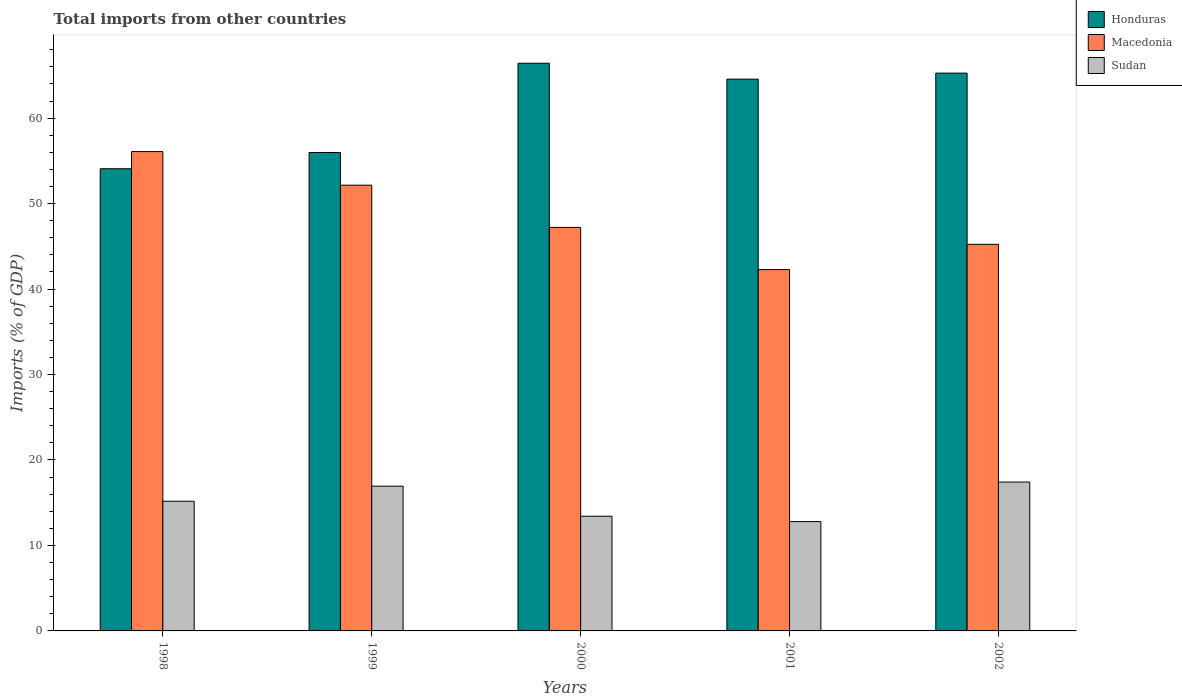How many different coloured bars are there?
Your response must be concise. 3. How many groups of bars are there?
Offer a very short reply. 5. Are the number of bars per tick equal to the number of legend labels?
Your response must be concise. Yes. Are the number of bars on each tick of the X-axis equal?
Your response must be concise. Yes. How many bars are there on the 2nd tick from the right?
Your response must be concise. 3. What is the total imports in Macedonia in 1999?
Provide a succinct answer. 52.15. Across all years, what is the maximum total imports in Sudan?
Make the answer very short. 17.42. Across all years, what is the minimum total imports in Macedonia?
Offer a very short reply. 42.28. What is the total total imports in Macedonia in the graph?
Keep it short and to the point. 242.96. What is the difference between the total imports in Honduras in 1998 and that in 1999?
Provide a succinct answer. -1.9. What is the difference between the total imports in Sudan in 2002 and the total imports in Honduras in 1999?
Your answer should be compact. -38.56. What is the average total imports in Honduras per year?
Offer a terse response. 61.26. In the year 2001, what is the difference between the total imports in Honduras and total imports in Sudan?
Ensure brevity in your answer.  51.77. In how many years, is the total imports in Honduras greater than 10 %?
Make the answer very short. 5. What is the ratio of the total imports in Sudan in 1998 to that in 2001?
Ensure brevity in your answer.  1.19. Is the total imports in Sudan in 2001 less than that in 2002?
Provide a short and direct response. Yes. What is the difference between the highest and the second highest total imports in Sudan?
Give a very brief answer. 0.48. What is the difference between the highest and the lowest total imports in Sudan?
Make the answer very short. 4.62. In how many years, is the total imports in Honduras greater than the average total imports in Honduras taken over all years?
Provide a succinct answer. 3. What does the 1st bar from the left in 1999 represents?
Your response must be concise. Honduras. What does the 3rd bar from the right in 1999 represents?
Provide a short and direct response. Honduras. Is it the case that in every year, the sum of the total imports in Macedonia and total imports in Sudan is greater than the total imports in Honduras?
Keep it short and to the point. No. How many bars are there?
Offer a very short reply. 15. Are all the bars in the graph horizontal?
Offer a very short reply. No. How many years are there in the graph?
Ensure brevity in your answer.  5. What is the difference between two consecutive major ticks on the Y-axis?
Your response must be concise. 10. Where does the legend appear in the graph?
Offer a terse response. Top right. How many legend labels are there?
Provide a short and direct response. 3. How are the legend labels stacked?
Provide a short and direct response. Vertical. What is the title of the graph?
Offer a very short reply. Total imports from other countries. Does "Turkey" appear as one of the legend labels in the graph?
Ensure brevity in your answer.  No. What is the label or title of the X-axis?
Provide a short and direct response. Years. What is the label or title of the Y-axis?
Keep it short and to the point. Imports (% of GDP). What is the Imports (% of GDP) in Honduras in 1998?
Give a very brief answer. 54.08. What is the Imports (% of GDP) in Macedonia in 1998?
Give a very brief answer. 56.09. What is the Imports (% of GDP) of Sudan in 1998?
Provide a short and direct response. 15.17. What is the Imports (% of GDP) of Honduras in 1999?
Keep it short and to the point. 55.98. What is the Imports (% of GDP) of Macedonia in 1999?
Make the answer very short. 52.15. What is the Imports (% of GDP) in Sudan in 1999?
Ensure brevity in your answer.  16.93. What is the Imports (% of GDP) in Honduras in 2000?
Keep it short and to the point. 66.42. What is the Imports (% of GDP) of Macedonia in 2000?
Your answer should be very brief. 47.21. What is the Imports (% of GDP) in Sudan in 2000?
Keep it short and to the point. 13.42. What is the Imports (% of GDP) of Honduras in 2001?
Your answer should be very brief. 64.56. What is the Imports (% of GDP) of Macedonia in 2001?
Give a very brief answer. 42.28. What is the Imports (% of GDP) of Sudan in 2001?
Give a very brief answer. 12.8. What is the Imports (% of GDP) of Honduras in 2002?
Your answer should be very brief. 65.27. What is the Imports (% of GDP) of Macedonia in 2002?
Make the answer very short. 45.23. What is the Imports (% of GDP) of Sudan in 2002?
Your answer should be very brief. 17.42. Across all years, what is the maximum Imports (% of GDP) of Honduras?
Offer a very short reply. 66.42. Across all years, what is the maximum Imports (% of GDP) of Macedonia?
Keep it short and to the point. 56.09. Across all years, what is the maximum Imports (% of GDP) in Sudan?
Your answer should be compact. 17.42. Across all years, what is the minimum Imports (% of GDP) of Honduras?
Keep it short and to the point. 54.08. Across all years, what is the minimum Imports (% of GDP) of Macedonia?
Your answer should be very brief. 42.28. Across all years, what is the minimum Imports (% of GDP) in Sudan?
Offer a very short reply. 12.8. What is the total Imports (% of GDP) of Honduras in the graph?
Give a very brief answer. 306.31. What is the total Imports (% of GDP) in Macedonia in the graph?
Give a very brief answer. 242.96. What is the total Imports (% of GDP) in Sudan in the graph?
Your response must be concise. 75.74. What is the difference between the Imports (% of GDP) of Honduras in 1998 and that in 1999?
Your answer should be compact. -1.9. What is the difference between the Imports (% of GDP) in Macedonia in 1998 and that in 1999?
Ensure brevity in your answer.  3.93. What is the difference between the Imports (% of GDP) of Sudan in 1998 and that in 1999?
Give a very brief answer. -1.76. What is the difference between the Imports (% of GDP) in Honduras in 1998 and that in 2000?
Your response must be concise. -12.34. What is the difference between the Imports (% of GDP) in Macedonia in 1998 and that in 2000?
Give a very brief answer. 8.87. What is the difference between the Imports (% of GDP) of Sudan in 1998 and that in 2000?
Offer a very short reply. 1.75. What is the difference between the Imports (% of GDP) in Honduras in 1998 and that in 2001?
Your answer should be very brief. -10.48. What is the difference between the Imports (% of GDP) in Macedonia in 1998 and that in 2001?
Ensure brevity in your answer.  13.81. What is the difference between the Imports (% of GDP) in Sudan in 1998 and that in 2001?
Your answer should be compact. 2.38. What is the difference between the Imports (% of GDP) in Honduras in 1998 and that in 2002?
Give a very brief answer. -11.19. What is the difference between the Imports (% of GDP) in Macedonia in 1998 and that in 2002?
Give a very brief answer. 10.85. What is the difference between the Imports (% of GDP) in Sudan in 1998 and that in 2002?
Give a very brief answer. -2.24. What is the difference between the Imports (% of GDP) in Honduras in 1999 and that in 2000?
Ensure brevity in your answer.  -10.44. What is the difference between the Imports (% of GDP) in Macedonia in 1999 and that in 2000?
Ensure brevity in your answer.  4.94. What is the difference between the Imports (% of GDP) of Sudan in 1999 and that in 2000?
Provide a succinct answer. 3.52. What is the difference between the Imports (% of GDP) of Honduras in 1999 and that in 2001?
Ensure brevity in your answer.  -8.58. What is the difference between the Imports (% of GDP) of Macedonia in 1999 and that in 2001?
Ensure brevity in your answer.  9.87. What is the difference between the Imports (% of GDP) in Sudan in 1999 and that in 2001?
Give a very brief answer. 4.14. What is the difference between the Imports (% of GDP) in Honduras in 1999 and that in 2002?
Give a very brief answer. -9.29. What is the difference between the Imports (% of GDP) of Macedonia in 1999 and that in 2002?
Your answer should be compact. 6.92. What is the difference between the Imports (% of GDP) in Sudan in 1999 and that in 2002?
Keep it short and to the point. -0.48. What is the difference between the Imports (% of GDP) of Honduras in 2000 and that in 2001?
Make the answer very short. 1.86. What is the difference between the Imports (% of GDP) in Macedonia in 2000 and that in 2001?
Provide a succinct answer. 4.93. What is the difference between the Imports (% of GDP) of Sudan in 2000 and that in 2001?
Your answer should be very brief. 0.62. What is the difference between the Imports (% of GDP) in Honduras in 2000 and that in 2002?
Give a very brief answer. 1.15. What is the difference between the Imports (% of GDP) in Macedonia in 2000 and that in 2002?
Offer a terse response. 1.98. What is the difference between the Imports (% of GDP) in Sudan in 2000 and that in 2002?
Keep it short and to the point. -4. What is the difference between the Imports (% of GDP) in Honduras in 2001 and that in 2002?
Keep it short and to the point. -0.71. What is the difference between the Imports (% of GDP) of Macedonia in 2001 and that in 2002?
Ensure brevity in your answer.  -2.95. What is the difference between the Imports (% of GDP) of Sudan in 2001 and that in 2002?
Make the answer very short. -4.62. What is the difference between the Imports (% of GDP) of Honduras in 1998 and the Imports (% of GDP) of Macedonia in 1999?
Provide a short and direct response. 1.93. What is the difference between the Imports (% of GDP) in Honduras in 1998 and the Imports (% of GDP) in Sudan in 1999?
Provide a short and direct response. 37.14. What is the difference between the Imports (% of GDP) of Macedonia in 1998 and the Imports (% of GDP) of Sudan in 1999?
Your response must be concise. 39.15. What is the difference between the Imports (% of GDP) in Honduras in 1998 and the Imports (% of GDP) in Macedonia in 2000?
Keep it short and to the point. 6.87. What is the difference between the Imports (% of GDP) of Honduras in 1998 and the Imports (% of GDP) of Sudan in 2000?
Give a very brief answer. 40.66. What is the difference between the Imports (% of GDP) in Macedonia in 1998 and the Imports (% of GDP) in Sudan in 2000?
Keep it short and to the point. 42.67. What is the difference between the Imports (% of GDP) of Honduras in 1998 and the Imports (% of GDP) of Macedonia in 2001?
Your answer should be compact. 11.8. What is the difference between the Imports (% of GDP) of Honduras in 1998 and the Imports (% of GDP) of Sudan in 2001?
Keep it short and to the point. 41.28. What is the difference between the Imports (% of GDP) of Macedonia in 1998 and the Imports (% of GDP) of Sudan in 2001?
Ensure brevity in your answer.  43.29. What is the difference between the Imports (% of GDP) of Honduras in 1998 and the Imports (% of GDP) of Macedonia in 2002?
Give a very brief answer. 8.85. What is the difference between the Imports (% of GDP) of Honduras in 1998 and the Imports (% of GDP) of Sudan in 2002?
Ensure brevity in your answer.  36.66. What is the difference between the Imports (% of GDP) of Macedonia in 1998 and the Imports (% of GDP) of Sudan in 2002?
Your response must be concise. 38.67. What is the difference between the Imports (% of GDP) in Honduras in 1999 and the Imports (% of GDP) in Macedonia in 2000?
Provide a short and direct response. 8.77. What is the difference between the Imports (% of GDP) in Honduras in 1999 and the Imports (% of GDP) in Sudan in 2000?
Keep it short and to the point. 42.56. What is the difference between the Imports (% of GDP) in Macedonia in 1999 and the Imports (% of GDP) in Sudan in 2000?
Provide a short and direct response. 38.73. What is the difference between the Imports (% of GDP) of Honduras in 1999 and the Imports (% of GDP) of Macedonia in 2001?
Provide a short and direct response. 13.7. What is the difference between the Imports (% of GDP) of Honduras in 1999 and the Imports (% of GDP) of Sudan in 2001?
Give a very brief answer. 43.18. What is the difference between the Imports (% of GDP) in Macedonia in 1999 and the Imports (% of GDP) in Sudan in 2001?
Provide a succinct answer. 39.36. What is the difference between the Imports (% of GDP) of Honduras in 1999 and the Imports (% of GDP) of Macedonia in 2002?
Ensure brevity in your answer.  10.75. What is the difference between the Imports (% of GDP) in Honduras in 1999 and the Imports (% of GDP) in Sudan in 2002?
Make the answer very short. 38.56. What is the difference between the Imports (% of GDP) in Macedonia in 1999 and the Imports (% of GDP) in Sudan in 2002?
Your answer should be very brief. 34.74. What is the difference between the Imports (% of GDP) in Honduras in 2000 and the Imports (% of GDP) in Macedonia in 2001?
Provide a short and direct response. 24.14. What is the difference between the Imports (% of GDP) in Honduras in 2000 and the Imports (% of GDP) in Sudan in 2001?
Your response must be concise. 53.62. What is the difference between the Imports (% of GDP) of Macedonia in 2000 and the Imports (% of GDP) of Sudan in 2001?
Your answer should be very brief. 34.42. What is the difference between the Imports (% of GDP) in Honduras in 2000 and the Imports (% of GDP) in Macedonia in 2002?
Give a very brief answer. 21.19. What is the difference between the Imports (% of GDP) in Honduras in 2000 and the Imports (% of GDP) in Sudan in 2002?
Ensure brevity in your answer.  49. What is the difference between the Imports (% of GDP) in Macedonia in 2000 and the Imports (% of GDP) in Sudan in 2002?
Your answer should be very brief. 29.8. What is the difference between the Imports (% of GDP) of Honduras in 2001 and the Imports (% of GDP) of Macedonia in 2002?
Provide a short and direct response. 19.33. What is the difference between the Imports (% of GDP) in Honduras in 2001 and the Imports (% of GDP) in Sudan in 2002?
Your response must be concise. 47.14. What is the difference between the Imports (% of GDP) of Macedonia in 2001 and the Imports (% of GDP) of Sudan in 2002?
Provide a short and direct response. 24.86. What is the average Imports (% of GDP) of Honduras per year?
Make the answer very short. 61.26. What is the average Imports (% of GDP) of Macedonia per year?
Ensure brevity in your answer.  48.59. What is the average Imports (% of GDP) in Sudan per year?
Provide a short and direct response. 15.15. In the year 1998, what is the difference between the Imports (% of GDP) in Honduras and Imports (% of GDP) in Macedonia?
Offer a very short reply. -2.01. In the year 1998, what is the difference between the Imports (% of GDP) of Honduras and Imports (% of GDP) of Sudan?
Provide a succinct answer. 38.91. In the year 1998, what is the difference between the Imports (% of GDP) of Macedonia and Imports (% of GDP) of Sudan?
Your response must be concise. 40.91. In the year 1999, what is the difference between the Imports (% of GDP) of Honduras and Imports (% of GDP) of Macedonia?
Offer a very short reply. 3.82. In the year 1999, what is the difference between the Imports (% of GDP) in Honduras and Imports (% of GDP) in Sudan?
Your response must be concise. 39.04. In the year 1999, what is the difference between the Imports (% of GDP) of Macedonia and Imports (% of GDP) of Sudan?
Give a very brief answer. 35.22. In the year 2000, what is the difference between the Imports (% of GDP) in Honduras and Imports (% of GDP) in Macedonia?
Make the answer very short. 19.21. In the year 2000, what is the difference between the Imports (% of GDP) in Honduras and Imports (% of GDP) in Sudan?
Provide a short and direct response. 53. In the year 2000, what is the difference between the Imports (% of GDP) in Macedonia and Imports (% of GDP) in Sudan?
Your answer should be compact. 33.79. In the year 2001, what is the difference between the Imports (% of GDP) in Honduras and Imports (% of GDP) in Macedonia?
Offer a very short reply. 22.28. In the year 2001, what is the difference between the Imports (% of GDP) in Honduras and Imports (% of GDP) in Sudan?
Provide a succinct answer. 51.77. In the year 2001, what is the difference between the Imports (% of GDP) in Macedonia and Imports (% of GDP) in Sudan?
Ensure brevity in your answer.  29.48. In the year 2002, what is the difference between the Imports (% of GDP) of Honduras and Imports (% of GDP) of Macedonia?
Make the answer very short. 20.03. In the year 2002, what is the difference between the Imports (% of GDP) in Honduras and Imports (% of GDP) in Sudan?
Your answer should be compact. 47.85. In the year 2002, what is the difference between the Imports (% of GDP) in Macedonia and Imports (% of GDP) in Sudan?
Offer a very short reply. 27.82. What is the ratio of the Imports (% of GDP) in Honduras in 1998 to that in 1999?
Ensure brevity in your answer.  0.97. What is the ratio of the Imports (% of GDP) of Macedonia in 1998 to that in 1999?
Your answer should be compact. 1.08. What is the ratio of the Imports (% of GDP) in Sudan in 1998 to that in 1999?
Keep it short and to the point. 0.9. What is the ratio of the Imports (% of GDP) of Honduras in 1998 to that in 2000?
Your answer should be very brief. 0.81. What is the ratio of the Imports (% of GDP) of Macedonia in 1998 to that in 2000?
Your response must be concise. 1.19. What is the ratio of the Imports (% of GDP) in Sudan in 1998 to that in 2000?
Make the answer very short. 1.13. What is the ratio of the Imports (% of GDP) in Honduras in 1998 to that in 2001?
Provide a short and direct response. 0.84. What is the ratio of the Imports (% of GDP) in Macedonia in 1998 to that in 2001?
Offer a terse response. 1.33. What is the ratio of the Imports (% of GDP) in Sudan in 1998 to that in 2001?
Make the answer very short. 1.19. What is the ratio of the Imports (% of GDP) of Honduras in 1998 to that in 2002?
Your response must be concise. 0.83. What is the ratio of the Imports (% of GDP) of Macedonia in 1998 to that in 2002?
Provide a short and direct response. 1.24. What is the ratio of the Imports (% of GDP) of Sudan in 1998 to that in 2002?
Ensure brevity in your answer.  0.87. What is the ratio of the Imports (% of GDP) of Honduras in 1999 to that in 2000?
Make the answer very short. 0.84. What is the ratio of the Imports (% of GDP) in Macedonia in 1999 to that in 2000?
Provide a short and direct response. 1.1. What is the ratio of the Imports (% of GDP) of Sudan in 1999 to that in 2000?
Keep it short and to the point. 1.26. What is the ratio of the Imports (% of GDP) of Honduras in 1999 to that in 2001?
Offer a very short reply. 0.87. What is the ratio of the Imports (% of GDP) of Macedonia in 1999 to that in 2001?
Your answer should be very brief. 1.23. What is the ratio of the Imports (% of GDP) in Sudan in 1999 to that in 2001?
Ensure brevity in your answer.  1.32. What is the ratio of the Imports (% of GDP) in Honduras in 1999 to that in 2002?
Offer a terse response. 0.86. What is the ratio of the Imports (% of GDP) of Macedonia in 1999 to that in 2002?
Provide a short and direct response. 1.15. What is the ratio of the Imports (% of GDP) of Sudan in 1999 to that in 2002?
Keep it short and to the point. 0.97. What is the ratio of the Imports (% of GDP) in Honduras in 2000 to that in 2001?
Provide a short and direct response. 1.03. What is the ratio of the Imports (% of GDP) in Macedonia in 2000 to that in 2001?
Ensure brevity in your answer.  1.12. What is the ratio of the Imports (% of GDP) of Sudan in 2000 to that in 2001?
Your answer should be very brief. 1.05. What is the ratio of the Imports (% of GDP) of Honduras in 2000 to that in 2002?
Your response must be concise. 1.02. What is the ratio of the Imports (% of GDP) in Macedonia in 2000 to that in 2002?
Make the answer very short. 1.04. What is the ratio of the Imports (% of GDP) of Sudan in 2000 to that in 2002?
Ensure brevity in your answer.  0.77. What is the ratio of the Imports (% of GDP) in Honduras in 2001 to that in 2002?
Ensure brevity in your answer.  0.99. What is the ratio of the Imports (% of GDP) of Macedonia in 2001 to that in 2002?
Give a very brief answer. 0.93. What is the ratio of the Imports (% of GDP) in Sudan in 2001 to that in 2002?
Provide a short and direct response. 0.73. What is the difference between the highest and the second highest Imports (% of GDP) of Honduras?
Your response must be concise. 1.15. What is the difference between the highest and the second highest Imports (% of GDP) in Macedonia?
Keep it short and to the point. 3.93. What is the difference between the highest and the second highest Imports (% of GDP) in Sudan?
Your response must be concise. 0.48. What is the difference between the highest and the lowest Imports (% of GDP) of Honduras?
Give a very brief answer. 12.34. What is the difference between the highest and the lowest Imports (% of GDP) of Macedonia?
Ensure brevity in your answer.  13.81. What is the difference between the highest and the lowest Imports (% of GDP) in Sudan?
Your answer should be very brief. 4.62. 